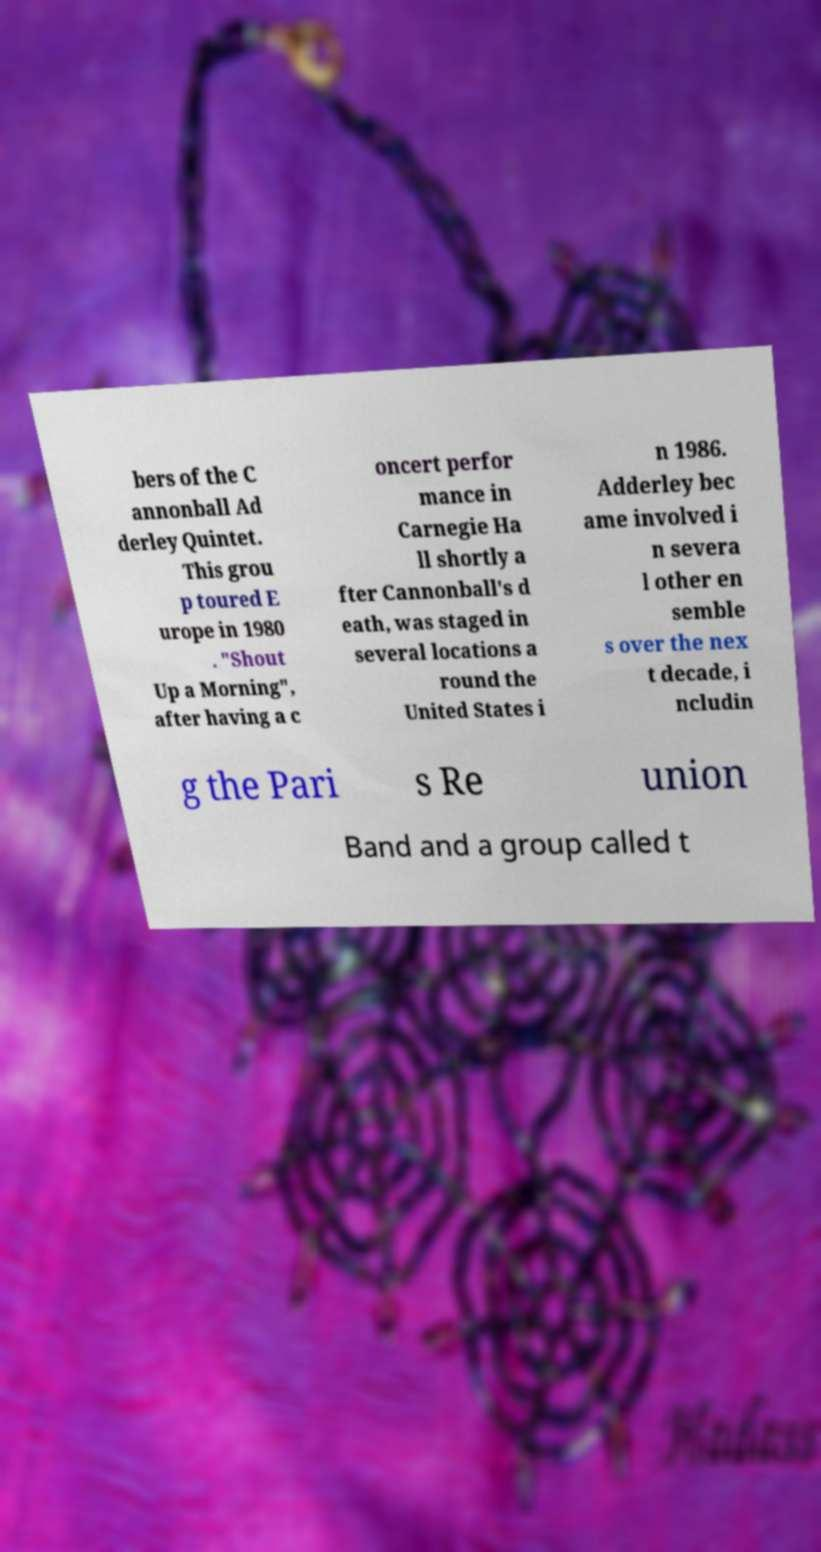Could you extract and type out the text from this image? bers of the C annonball Ad derley Quintet. This grou p toured E urope in 1980 . "Shout Up a Morning", after having a c oncert perfor mance in Carnegie Ha ll shortly a fter Cannonball's d eath, was staged in several locations a round the United States i n 1986. Adderley bec ame involved i n severa l other en semble s over the nex t decade, i ncludin g the Pari s Re union Band and a group called t 